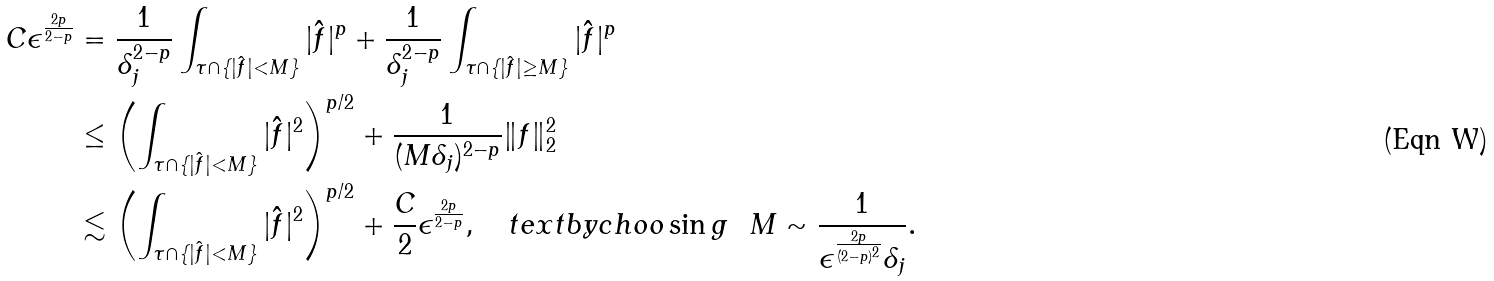Convert formula to latex. <formula><loc_0><loc_0><loc_500><loc_500>C \epsilon ^ { \frac { 2 p } { 2 - p } } & = \frac { 1 } { \delta _ { j } ^ { 2 - p } } \int _ { \tau \cap \{ | \hat { f } | < M \} } | \hat { f } | ^ { p } + \frac { 1 } { \delta _ { j } ^ { 2 - p } } \int _ { \tau \cap \{ | \hat { f } | \geq M \} } | \hat { f } | ^ { p } \\ & \leq \left ( \int _ { \tau \cap \{ | \hat { f } | < M \} } | \hat { f } | ^ { 2 } \right ) ^ { p / 2 } + \frac { 1 } { ( M \delta _ { j } ) ^ { 2 - p } } \| f \| _ { 2 } ^ { 2 } \\ & \lesssim \left ( \int _ { \tau \cap \{ | \hat { f } | < M \} } | \hat { f } | ^ { 2 } \right ) ^ { p / 2 } + \frac { C } { 2 } \epsilon ^ { \frac { 2 p } { 2 - p } } , \quad t e x t { b y c h o o \sin g } \ \ M \sim \frac { 1 } { \epsilon ^ { \frac { 2 p } { ( 2 - p ) ^ { 2 } } } \delta _ { j } } .</formula> 